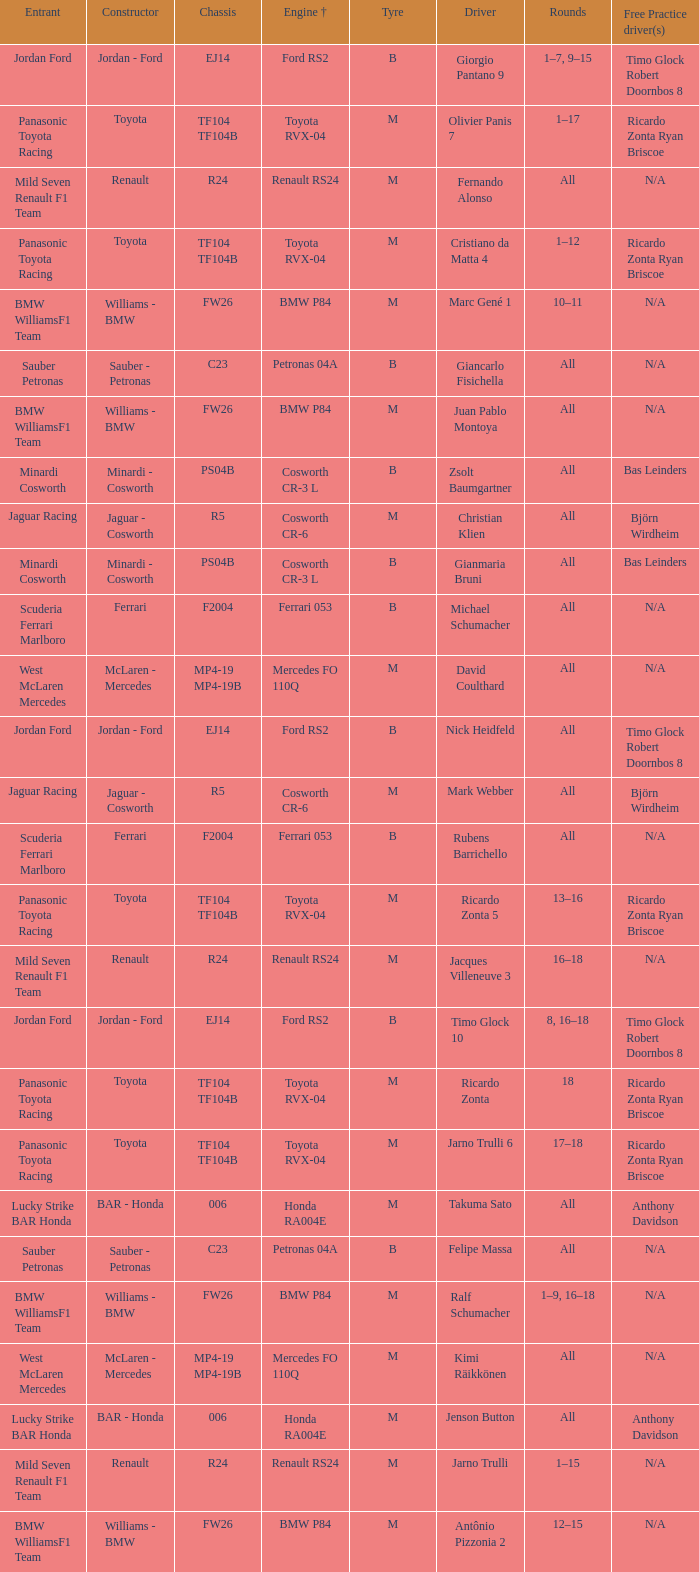What are the rounds for the B tyres and Ferrari 053 engine +? All, All. 